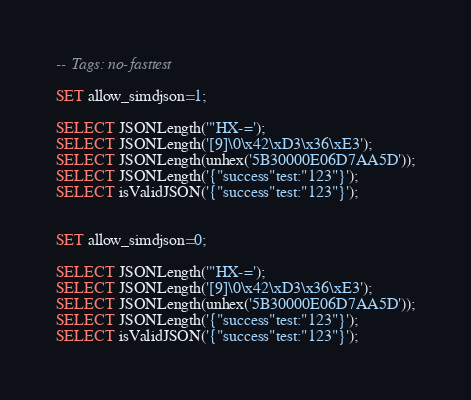Convert code to text. <code><loc_0><loc_0><loc_500><loc_500><_SQL_>-- Tags: no-fasttest

SET allow_simdjson=1;

SELECT JSONLength('"HX-=');
SELECT JSONLength('[9]\0\x42\xD3\x36\xE3');
SELECT JSONLength(unhex('5B30000E06D7AA5D'));
SELECT JSONLength('{"success"test:"123"}');
SELECT isValidJSON('{"success"test:"123"}');


SET allow_simdjson=0;

SELECT JSONLength('"HX-=');
SELECT JSONLength('[9]\0\x42\xD3\x36\xE3');
SELECT JSONLength(unhex('5B30000E06D7AA5D'));
SELECT JSONLength('{"success"test:"123"}');
SELECT isValidJSON('{"success"test:"123"}');
</code> 